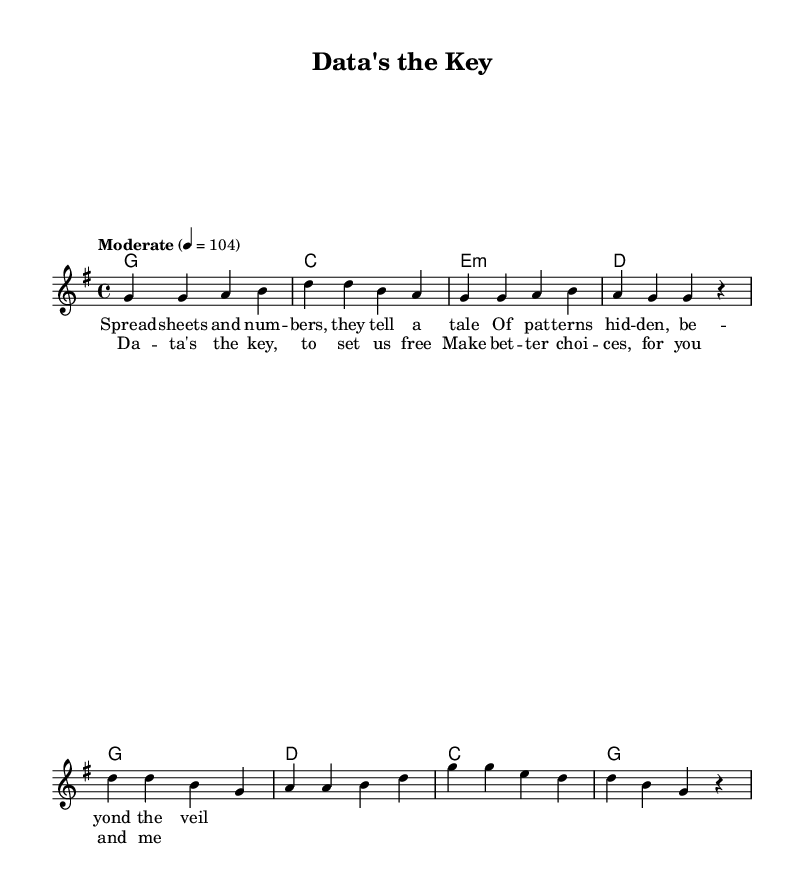What is the key signature of this music? The key signature indicated is G major, which has one sharp (F#). This is confirmed by the initial part of the score where it specifies "g \major".
Answer: G major What is the time signature of this music? The time signature is 4/4, which means there are four beats per measure and a quarter note gets one beat. This is explicitly stated in the score with "\time 4/4".
Answer: 4/4 What is the tempo of the piece? The tempo is specified as "Moderate" with a metronomic marking of 104, indicating the speed at which the piece should be played. This appears in the score as "tempo 'Moderate' 4 = 104".
Answer: Moderate, 104 What is the first lyric line of the verse? The first lyric line reads "Spread -- sheets and num -- bers, they tell a tale", which is directly noted under the melody in the verse section.
Answer: Spread sheets and numbers, they tell a tale How many measures are in the chorus? The chorus contains four measures as evident from the structure where four distinct musical phrases are grouped together, each corresponding to a line of lyrics. This is visually counted in the music notation.
Answer: Four What are the chord changes for the verse? The chord changes for the verse are G, C, E minor, and D, as listed in the chord section of the score labeled under "harmonies". Each chord corresponds sequentially to the measures in the verse.
Answer: G, C, E minor, D What is the main theme of the lyrics in the chorus? The main theme of the lyrics in the chorus is about utilizing data for making better choices, as expressed in the lines "Data's the key, to set us free". This reflects the overarching motif of decision-making based on data analysis.
Answer: Data's the key, to set us free 